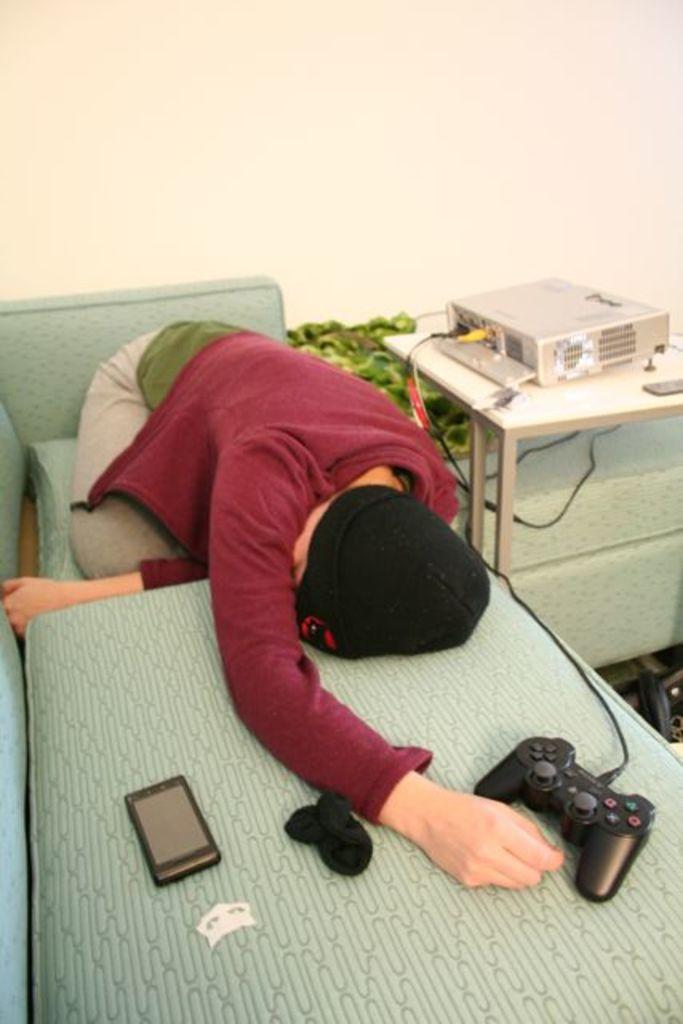What is the person in the image wearing on their upper body? The person is wearing a red jacket. What type of headwear is the person wearing? The person is wearing a black cap. Where is the person in the image located? The person is sleeping on a sofa. What object can be seen in the image that is commonly used for gaming? There is a joystick in the image, which is likely connected to a gaming console or device. What type of butter is being used to fan the person in the image? There is no butter or fan present in the image. What type of structure is visible in the background of the image? The provided facts do not mention any structure in the background of the image. 